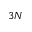Convert formula to latex. <formula><loc_0><loc_0><loc_500><loc_500>3 N</formula> 